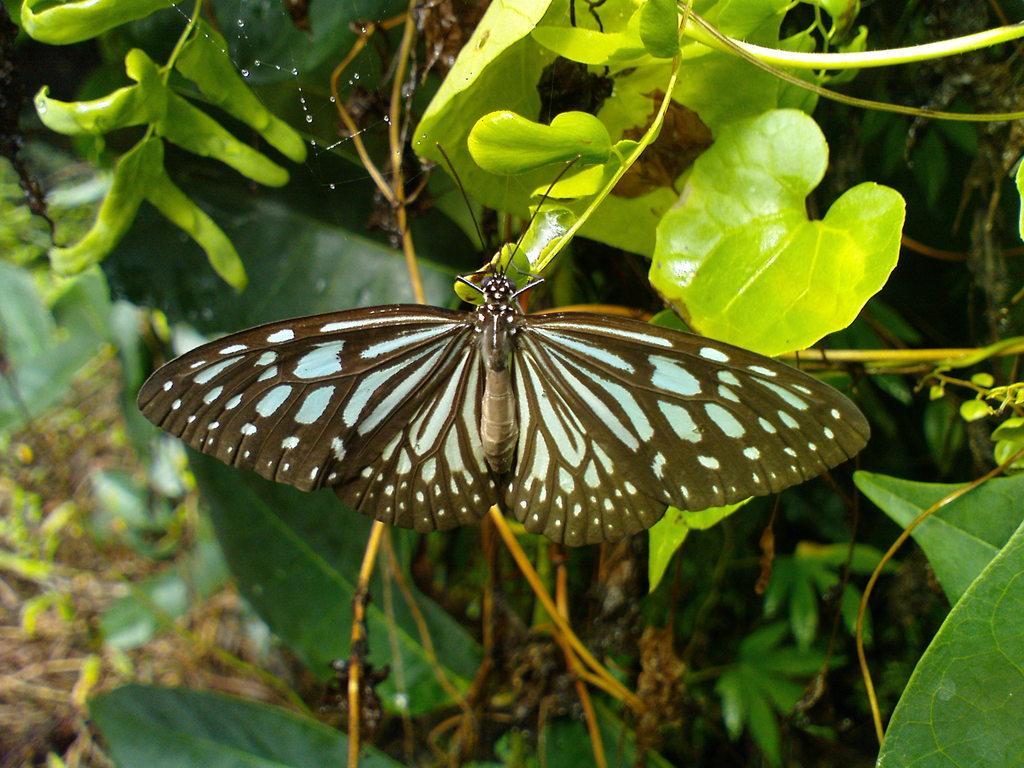In one or two sentences, can you explain what this image depicts? In this picture, we see a butterfly. In the background, we see the trees. On the left side, we see the twigs. This picture is blurred at the bottom. 